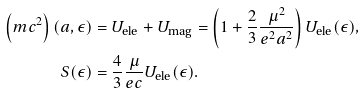Convert formula to latex. <formula><loc_0><loc_0><loc_500><loc_500>\left ( m c ^ { 2 } \right ) ( a , \epsilon ) & = U _ { \text {ele} } + U _ { \text {mag} } = \left ( 1 + \frac { 2 } { 3 } \frac { \mu ^ { 2 } } { e ^ { 2 } a ^ { 2 } } \right ) U _ { \text {ele} } ( \epsilon ) , \\ S ( \epsilon ) & = \frac { 4 } { 3 } \frac { \mu } { e c } U _ { \text {ele} } ( \epsilon ) .</formula> 